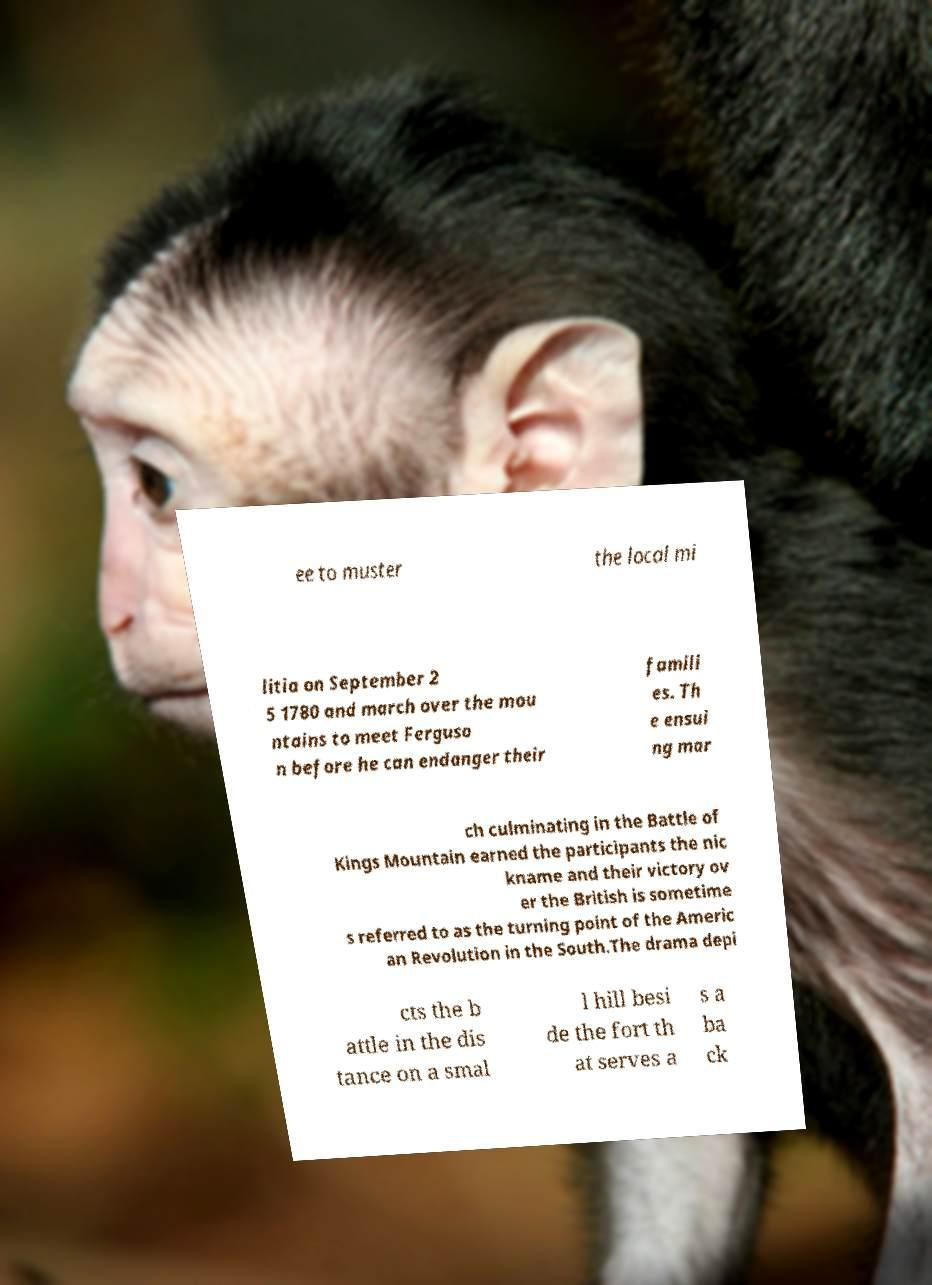Could you extract and type out the text from this image? ee to muster the local mi litia on September 2 5 1780 and march over the mou ntains to meet Ferguso n before he can endanger their famili es. Th e ensui ng mar ch culminating in the Battle of Kings Mountain earned the participants the nic kname and their victory ov er the British is sometime s referred to as the turning point of the Americ an Revolution in the South.The drama depi cts the b attle in the dis tance on a smal l hill besi de the fort th at serves a s a ba ck 